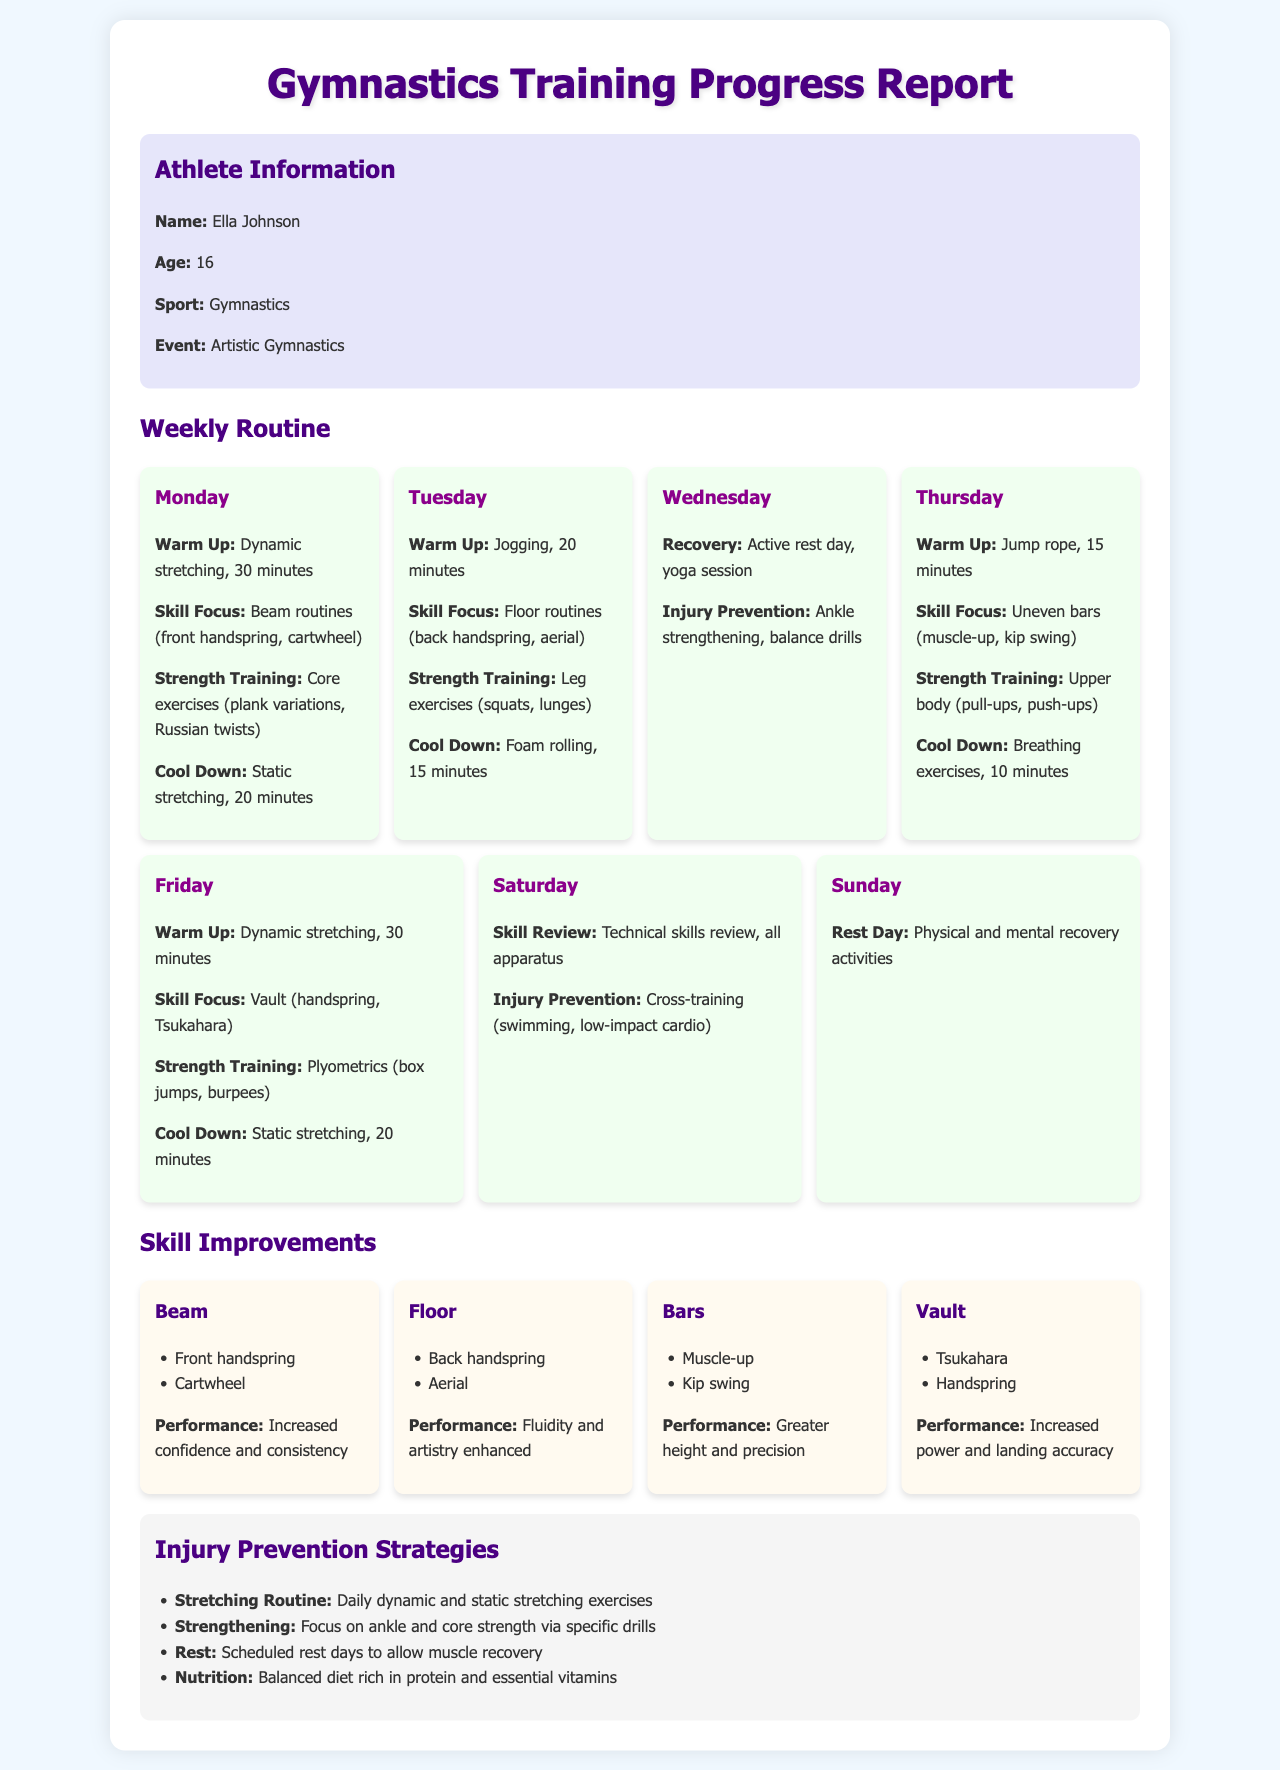What is the athlete's name? The athlete's name is stated in the athlete information section of the document.
Answer: Ella Johnson How old is Ella? Ella's age is mentioned in the athlete information section of the document.
Answer: 16 What day is the recovery session scheduled? The recovery session is detailed in the weekly routine section for Wednesday.
Answer: Wednesday Which skill was focused on during Tuesday's training? The skill focus for Tuesday is listed in the weekly routine section.
Answer: Floor routines What injury prevention activity was performed on Wednesday? The injury prevention activity for Wednesday is specified in the weekly routine section.
Answer: Ankle strengthening How many days are dedicated to skill reviews? The document outlines the number of days focused on skill reviews in the weekly routine section.
Answer: One day What are the main components of the injury prevention strategies? The injury prevention strategies are listed in a separate section detailing various approaches.
Answer: Stretching, Strengthening, Rest, Nutrition What exercise was included in strength training for Thursday? The strength training exercises for Thursday are mentioned in the weekly routine section.
Answer: Upper body (pull-ups, push-ups) What performance outcome is noted for the Beam skills? The performance outcome is summarized after the skill improvements listed in the document.
Answer: Increased confidence and consistency 